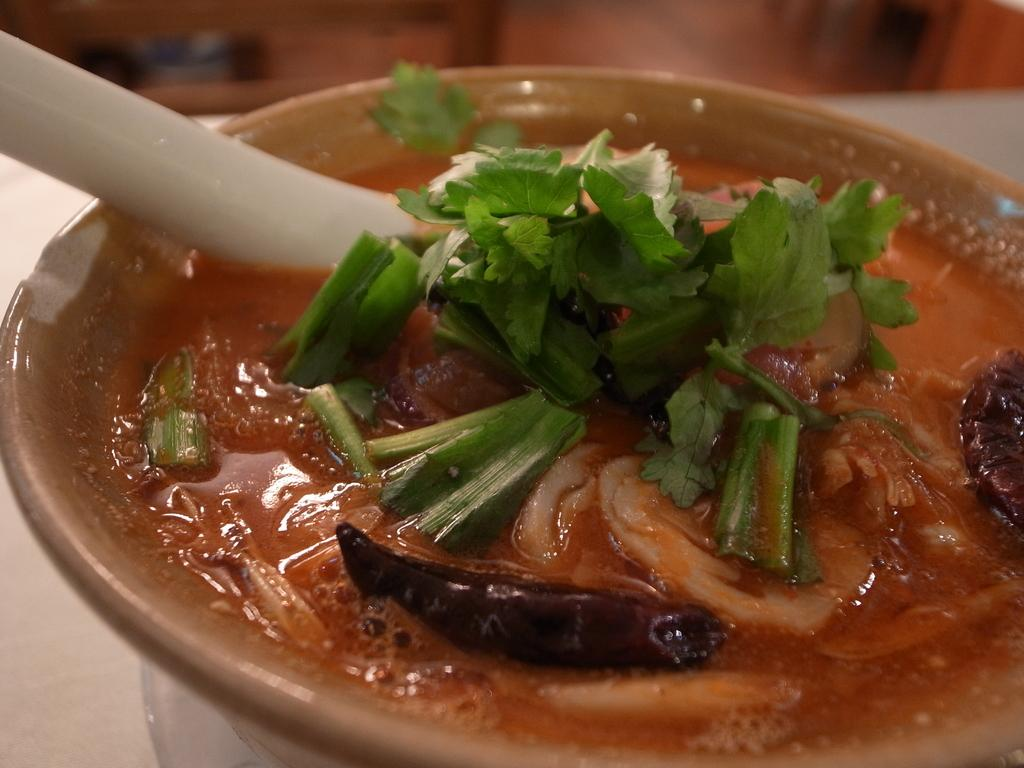What is in the bowl that is visible in the image? There is a bowl containing soup in the soup in the image. What utensil is present in the image? A spoon is visible in the image. Where are the bowl and spoon located? The bowl and spoon are placed on a table. How many boats are visible in the image? There are no boats present in the image. What type of frog can be seen sitting on the edge of the bowl? There is no frog present in the image. 